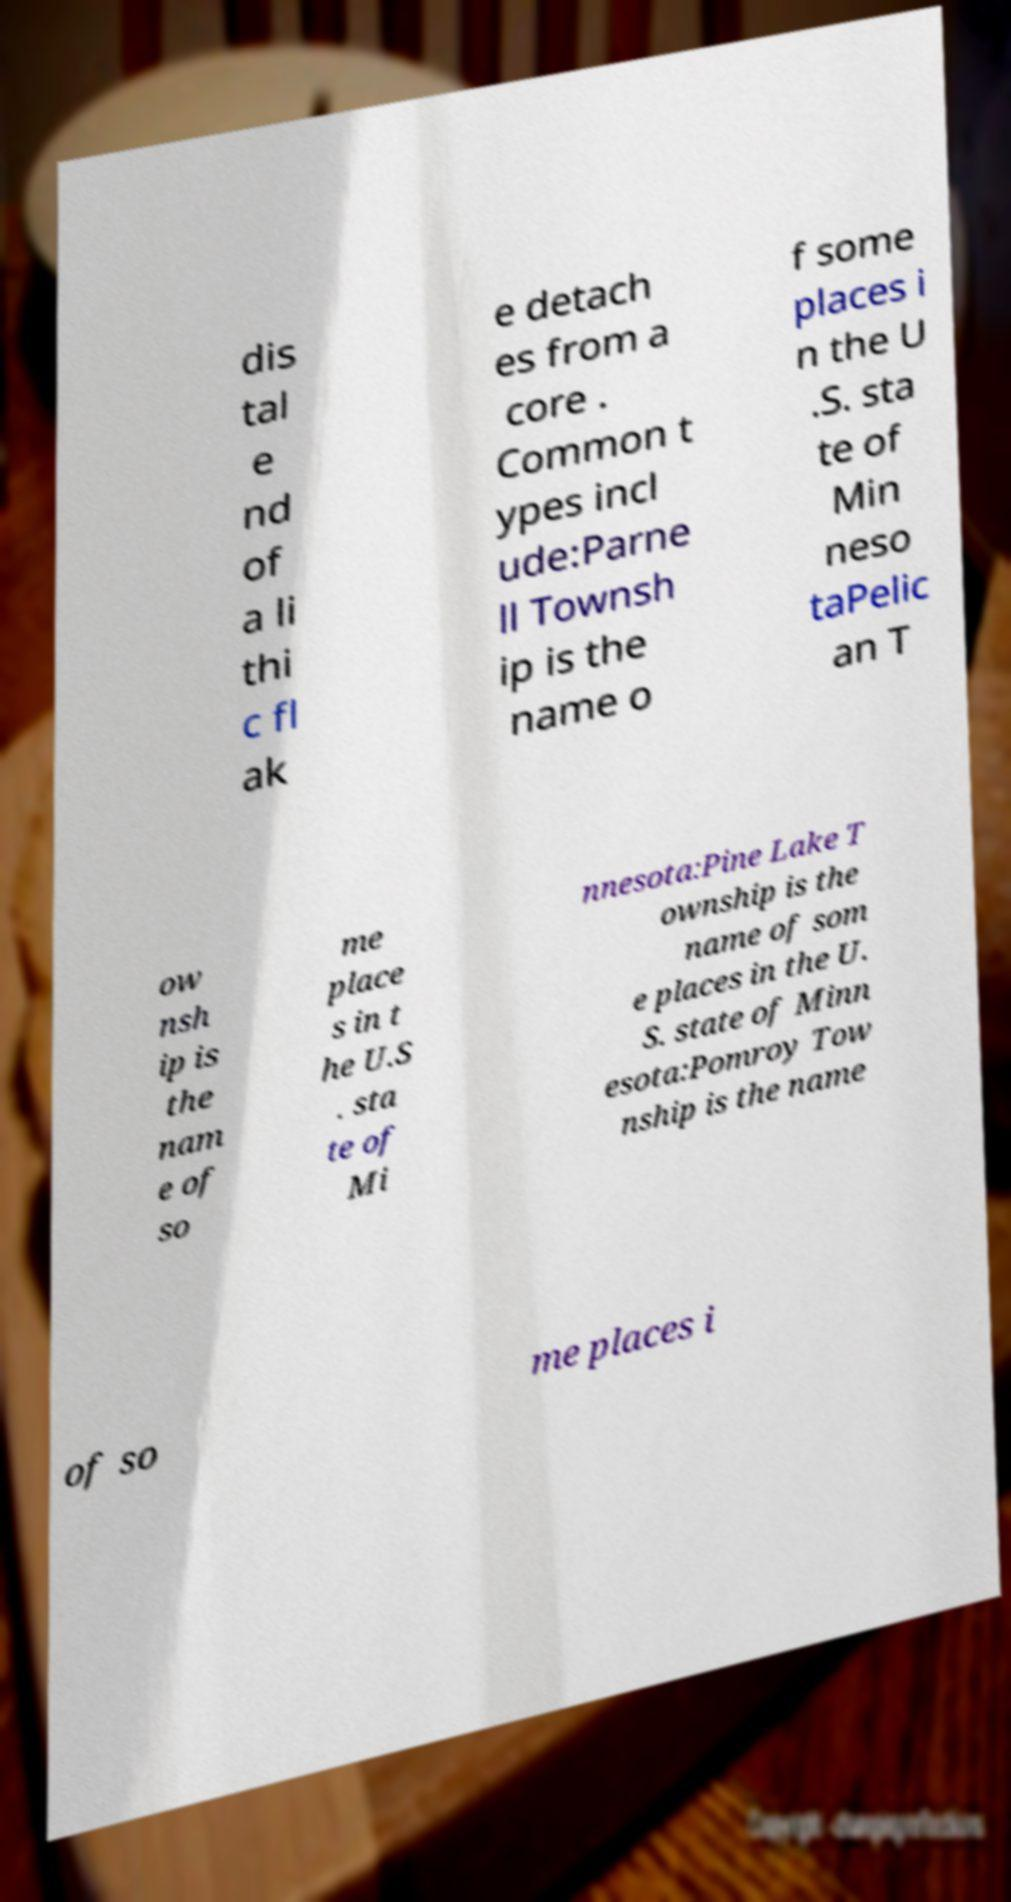What messages or text are displayed in this image? I need them in a readable, typed format. dis tal e nd of a li thi c fl ak e detach es from a core . Common t ypes incl ude:Parne ll Townsh ip is the name o f some places i n the U .S. sta te of Min neso taPelic an T ow nsh ip is the nam e of so me place s in t he U.S . sta te of Mi nnesota:Pine Lake T ownship is the name of som e places in the U. S. state of Minn esota:Pomroy Tow nship is the name of so me places i 